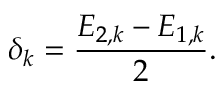<formula> <loc_0><loc_0><loc_500><loc_500>\delta _ { k } = \frac { E _ { 2 , k } - E _ { 1 , k } } { 2 } .</formula> 